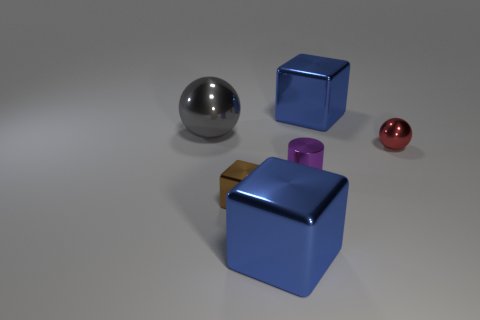Subtract all blue cubes. How many cubes are left? 1 Add 4 big metallic things. How many objects exist? 10 Subtract all brown cubes. How many cubes are left? 2 Subtract 1 cylinders. How many cylinders are left? 0 Add 4 tiny red things. How many tiny red things exist? 5 Subtract 1 red balls. How many objects are left? 5 Subtract all balls. How many objects are left? 4 Subtract all yellow cubes. Subtract all cyan spheres. How many cubes are left? 3 Subtract all yellow cubes. How many yellow cylinders are left? 0 Subtract all large shiny balls. Subtract all small red shiny cubes. How many objects are left? 5 